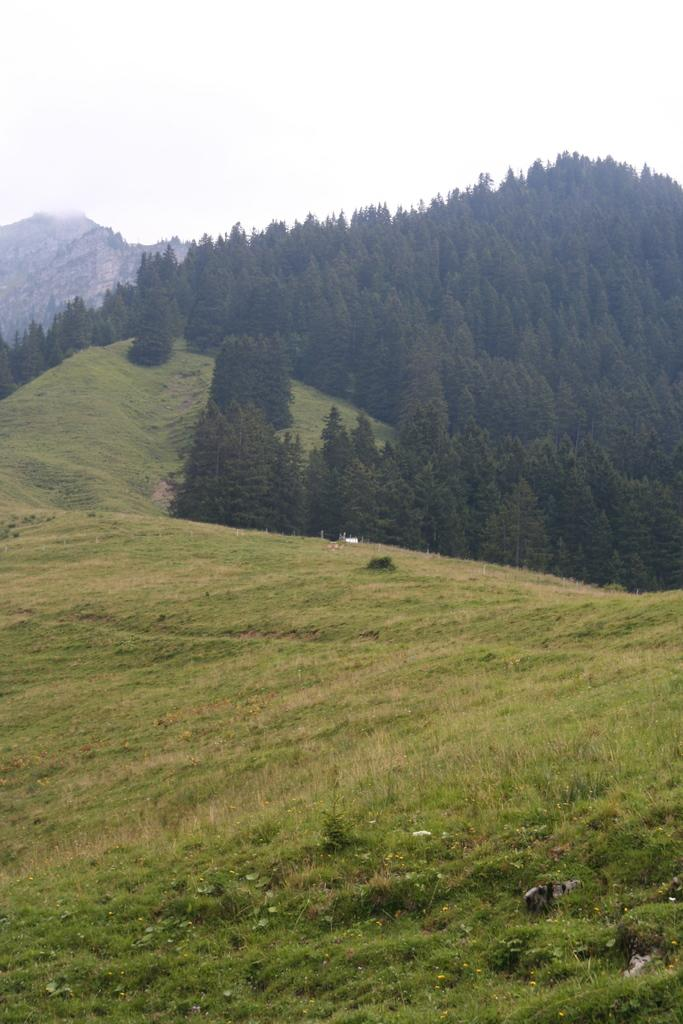What type of vegetation can be seen in the image? There are trees and grass in the image. What type of geographical feature is visible in the image? There are mountains in the image. What else can be seen in the image besides trees, grass, and mountains? There are other objects in the image. What is visible at the top of the image? The sky is visible at the top of the image. What type of vegetation is present at the bottom of the image? Grass and tiny plants are present at the bottom of the image. How many rabbits are sitting on the yoke in the image? There are no rabbits or yoke present in the image. What is the desire of the mountains in the image? The mountains do not have desires, as they are inanimate objects. 